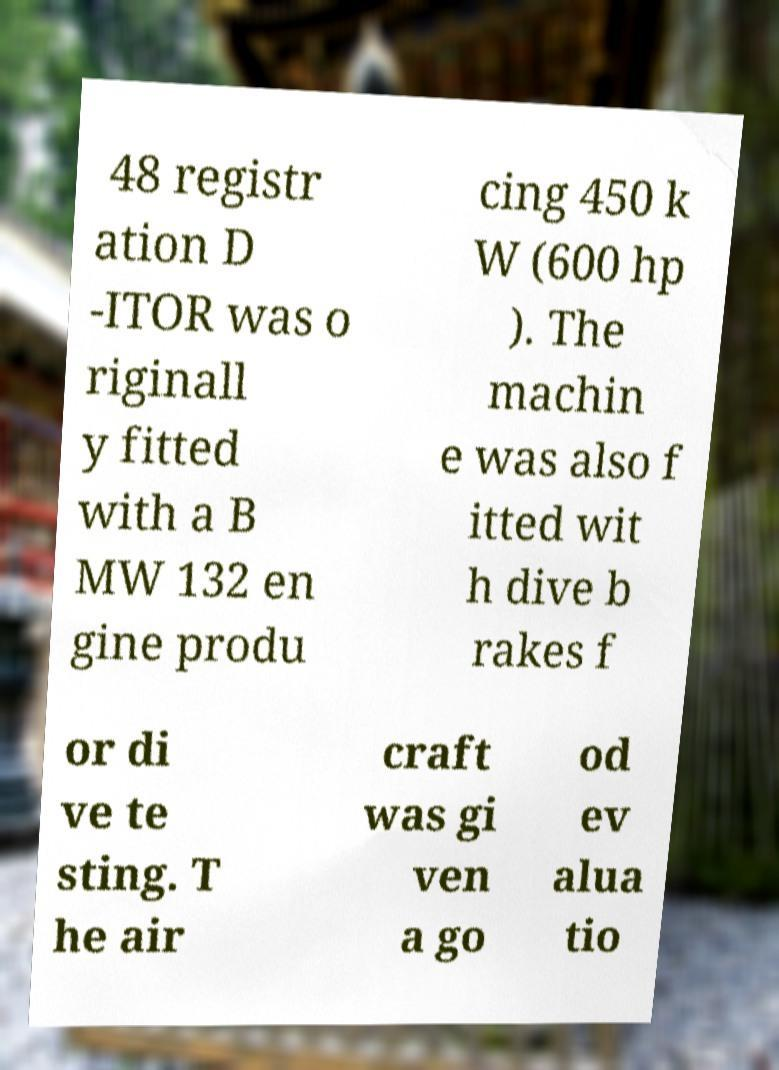Could you assist in decoding the text presented in this image and type it out clearly? 48 registr ation D -ITOR was o riginall y fitted with a B MW 132 en gine produ cing 450 k W (600 hp ). The machin e was also f itted wit h dive b rakes f or di ve te sting. T he air craft was gi ven a go od ev alua tio 